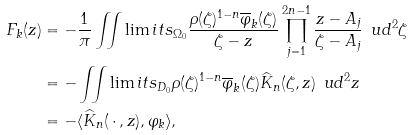<formula> <loc_0><loc_0><loc_500><loc_500>F _ { k } ( z ) & = - \frac { 1 } { \pi } \iint \lim i t s _ { \Omega _ { 0 } } \frac { \rho ( \zeta ) ^ { 1 - n } \overline { \varphi } _ { k } ( \zeta ) } { \zeta - z } \prod _ { j = 1 } ^ { 2 n - 1 } \frac { z - A _ { j } } { \zeta - A _ { j } } \, \ u d ^ { 2 } \zeta \\ & = - \iint \lim i t s _ { D _ { 0 } } \rho ( \zeta ) ^ { 1 - n } \overline { \varphi } _ { k } ( \zeta ) \widehat { K } _ { n } ( \zeta , z ) \, \ u d ^ { 2 } z \\ & = - \langle \widehat { K } _ { n } ( \, \cdot \, , z ) , \varphi _ { k } \rangle ,</formula> 